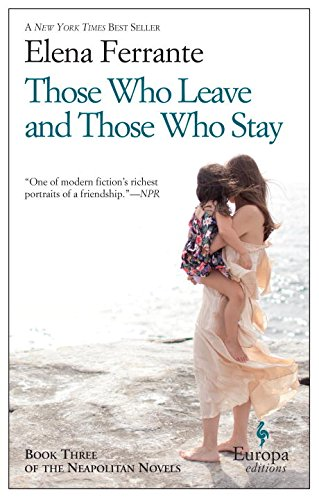Who wrote this book? The book is authored by Elena Ferrante, a renowned Italian novelist whose true identity remains pseudonymous, sparking intrigue in the literary world. 